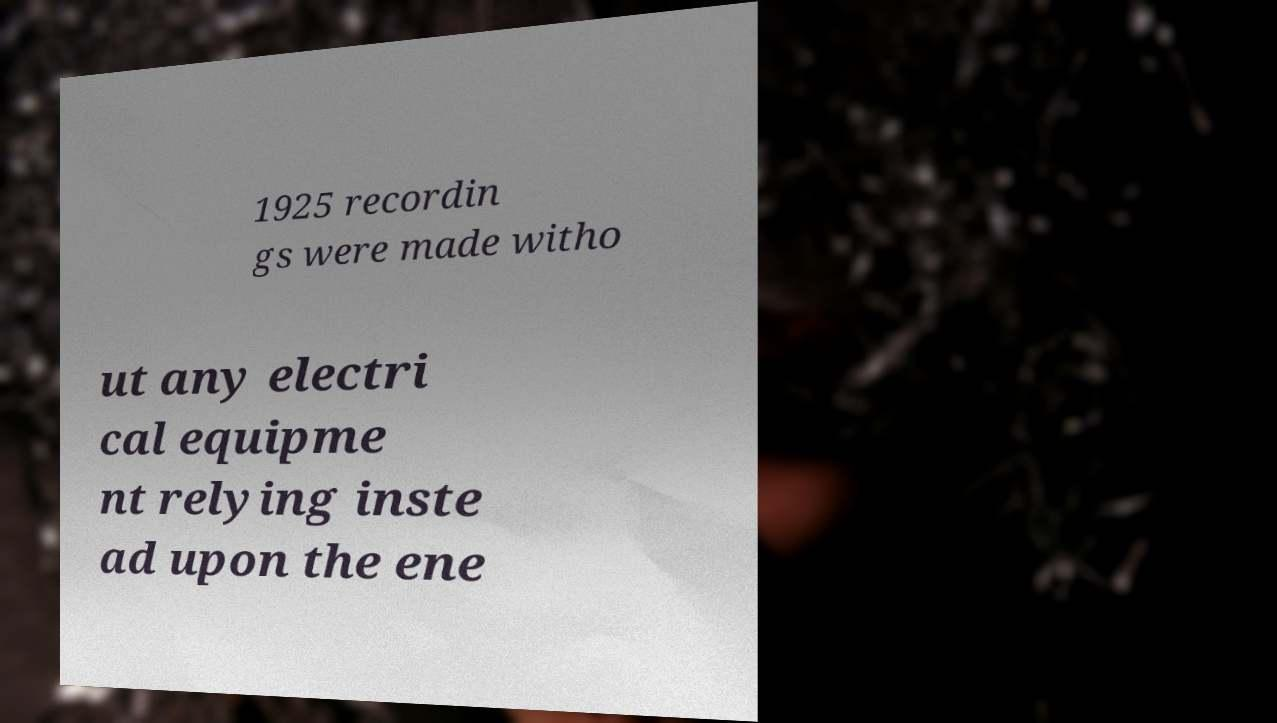Could you assist in decoding the text presented in this image and type it out clearly? 1925 recordin gs were made witho ut any electri cal equipme nt relying inste ad upon the ene 